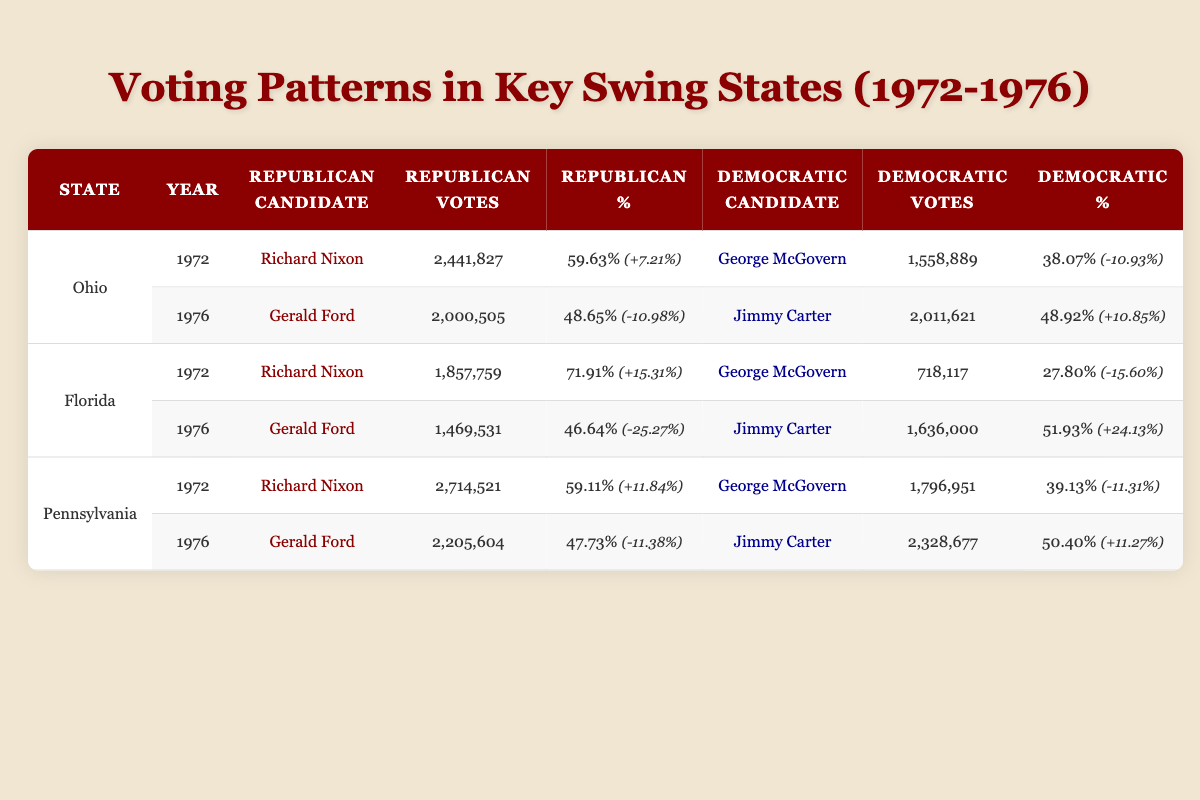What were the total votes for Richard Nixon in Ohio in 1972? The table shows that Richard Nixon received 2,441,827 votes in Ohio in 1972.
Answer: 2,441,827 Which candidate had the highest percentage of votes in Florida in 1972? According to the table, Richard Nixon garnered 71.91% of the votes in Florida in 1972, which is higher than George McGovern's 27.80%.
Answer: Richard Nixon Did Jimmy Carter win in Pennsylvania in 1976? The table indicates that Jimmy Carter received 2,328,677 votes, which amounted to 50.40% of the votes in Pennsylvania, surpassing Gerald Ford's 47.73%. Thus, he won.
Answer: Yes How many votes did Gerald Ford receive in Florida in 1976? The table reveals that Gerald Ford received 1,469,531 votes in Florida during the 1976 election.
Answer: 1,469,531 What is the swing percentage for George McGovern in Ohio from 1972 to 1976? In 1972, George McGovern had a percentage of 38.07%, and in 1976, he did not run. To find the swing, we look at Ford's and Carter's percentages: 48.65% (Ford) - 38.07% (McGovern) = 10.58% for the Democratic side, implying a change towards Ford.
Answer: N/A (he didn't run in 1976) Was there an increase or decrease in Republican votes in Florida from 1972 to 1976? Richard Nixon received 1,857,759 votes (71.91%) in 1972, whereas Gerald Ford received 1,469,531 votes (46.64%) in 1976. The number of votes fell by 388,228.
Answer: Decrease What was the total vote difference between Jimmy Carter and Gerald Ford in Pennsylvania in 1976? In Pennsylvania, Jimmy Carter received 2,328,677 votes and Gerald Ford received 2,205,604 votes. The difference is calculated as 2,328,677 - 2,205,604 = 123,073 votes.
Answer: 123,073 What was the overall trend in swing percentages for the Democratic candidates from 1972 to 1976? In 1972, Democratic candidates had negative swings in Ohio and Pennsylvania but a positive swing in Florida for 1976. In contrast, they showed an overall increase in both Ohio and Pennsylvania while winning Florida.
Answer: Overall increase in Democratic percentages 